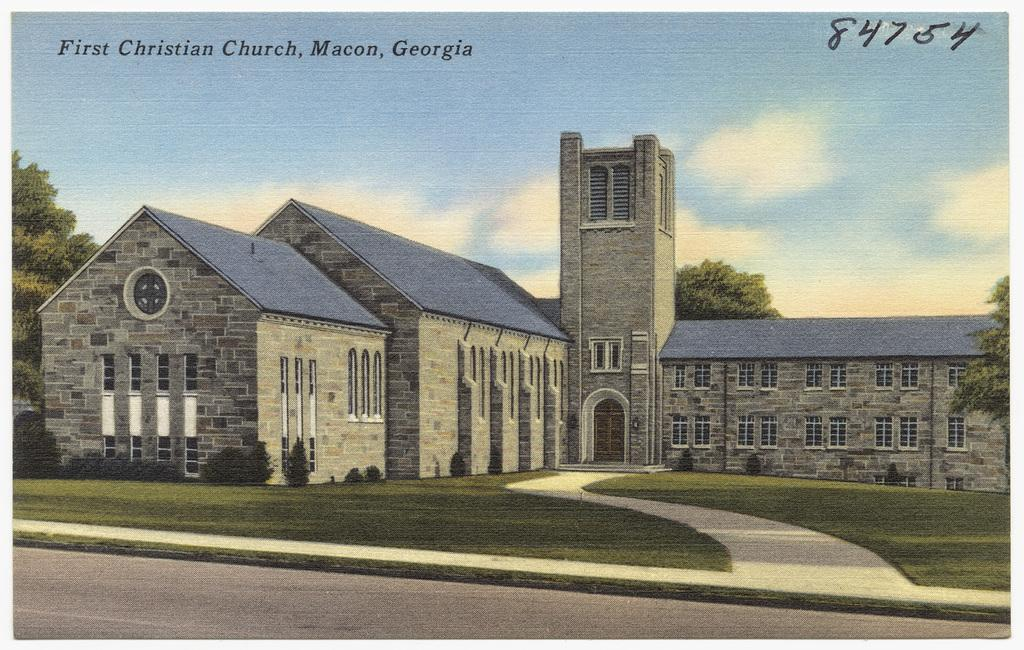What is the main subject of the image? The main subject of the image is a portrait of architecture. Are there any other elements present in the image besides the portrait of architecture? Yes, there are trees surrounding the portrait of architecture in the image. What type of knot is used to secure the seat in the image? There is no seat or knot present in the image; it features a portrait of architecture surrounded by trees. 